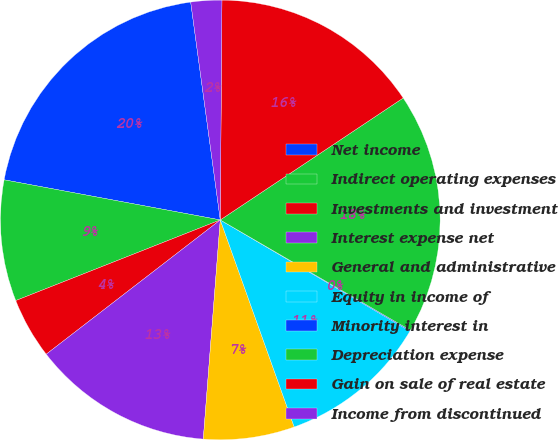<chart> <loc_0><loc_0><loc_500><loc_500><pie_chart><fcel>Net income<fcel>Indirect operating expenses<fcel>Investments and investment<fcel>Interest expense net<fcel>General and administrative<fcel>Equity in income of<fcel>Minority interest in<fcel>Depreciation expense<fcel>Gain on sale of real estate<fcel>Income from discontinued<nl><fcel>19.93%<fcel>8.9%<fcel>4.48%<fcel>13.31%<fcel>6.69%<fcel>11.1%<fcel>0.07%<fcel>17.73%<fcel>15.52%<fcel>2.27%<nl></chart> 